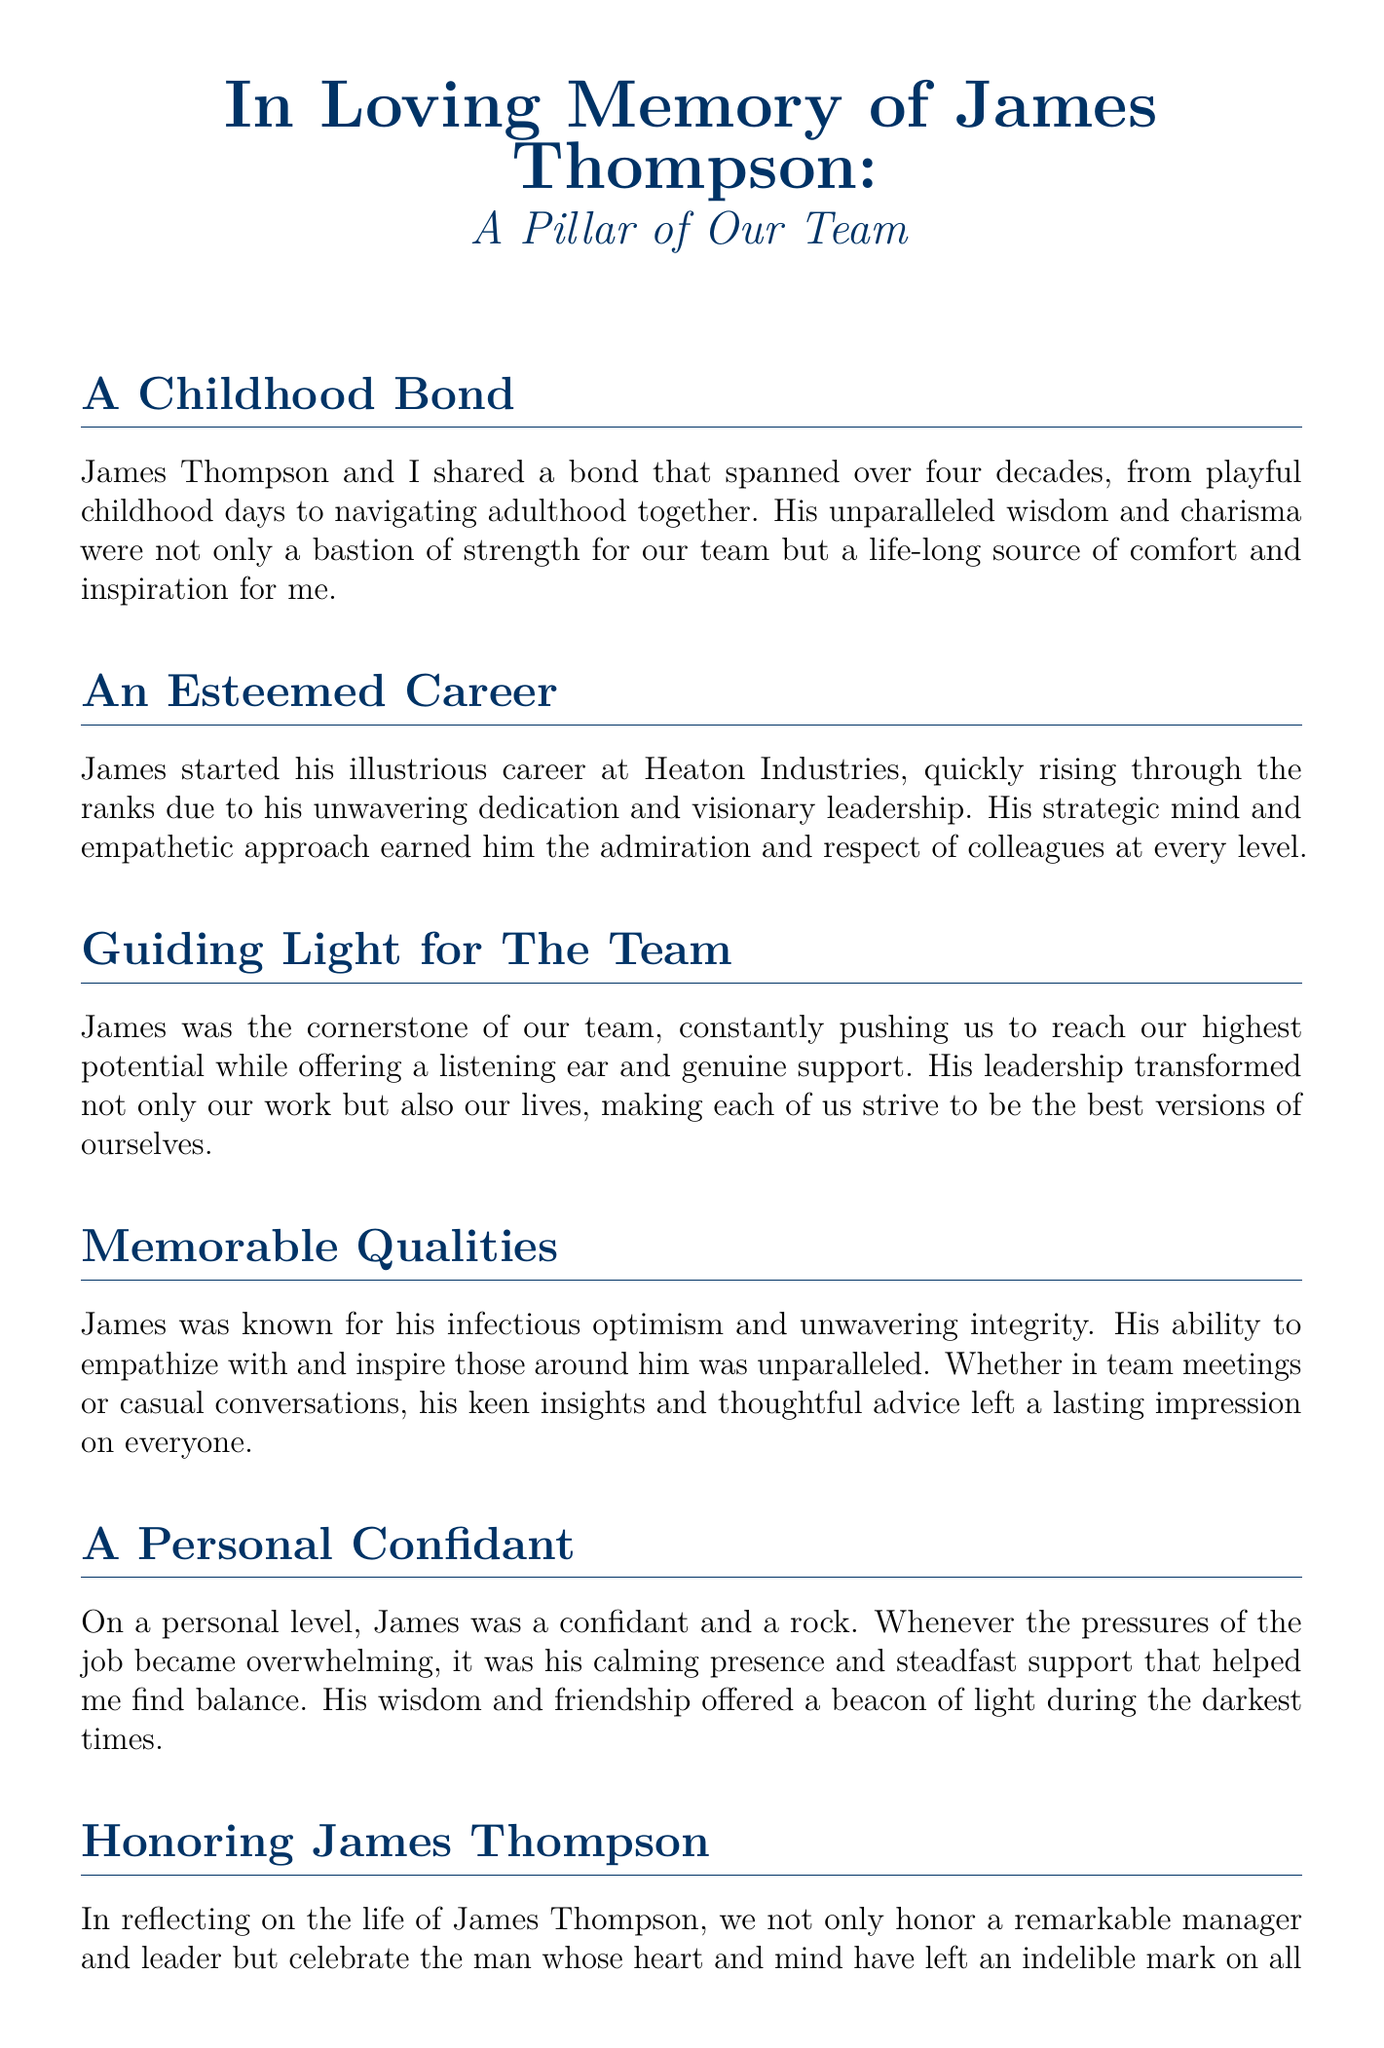What was James Thompson's last name? The document states that his full name is James Thompson.
Answer: Thompson How many decades did the bond between James and the author span? The document mentions four decades of friendship between James and the author.
Answer: Four What was James's role at Heaton Industries? The document indicates that James started his career at Heaton Industries and became a manager.
Answer: Manager What quality was James particularly known for? The document highlights his infectious optimism as a notable quality.
Answer: Optimism What type of support did James provide to the author during stressful times? The document describes James as providing steadfast support and a calming presence during overwhelming times.
Answer: Steadfast support In what capacity was James described as a "personal confidant"? The text specifies that James was a personal confidant and a rock for the author during pressures of the job.
Answer: Confidant What year does the document reflect on in relation to James's life? The document honors his life and reflects on his contributions, indicating a remembrance of his legacy rather than a specific year.
Answer: His legacy What did James inspire in his colleagues? The document mentions that James inspired his colleagues to strive to be the best versions of themselves.
Answer: Best versions What was the sentiment expressed regarding James's legacy? The document states that his legacy will be the foundation upon which others continue to build and grow.
Answer: Foundation 